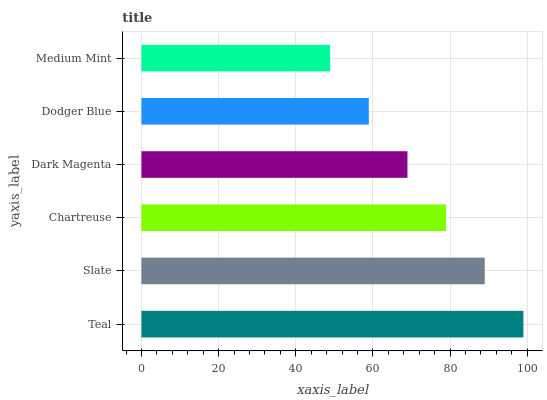Is Medium Mint the minimum?
Answer yes or no. Yes. Is Teal the maximum?
Answer yes or no. Yes. Is Slate the minimum?
Answer yes or no. No. Is Slate the maximum?
Answer yes or no. No. Is Teal greater than Slate?
Answer yes or no. Yes. Is Slate less than Teal?
Answer yes or no. Yes. Is Slate greater than Teal?
Answer yes or no. No. Is Teal less than Slate?
Answer yes or no. No. Is Chartreuse the high median?
Answer yes or no. Yes. Is Dark Magenta the low median?
Answer yes or no. Yes. Is Medium Mint the high median?
Answer yes or no. No. Is Chartreuse the low median?
Answer yes or no. No. 